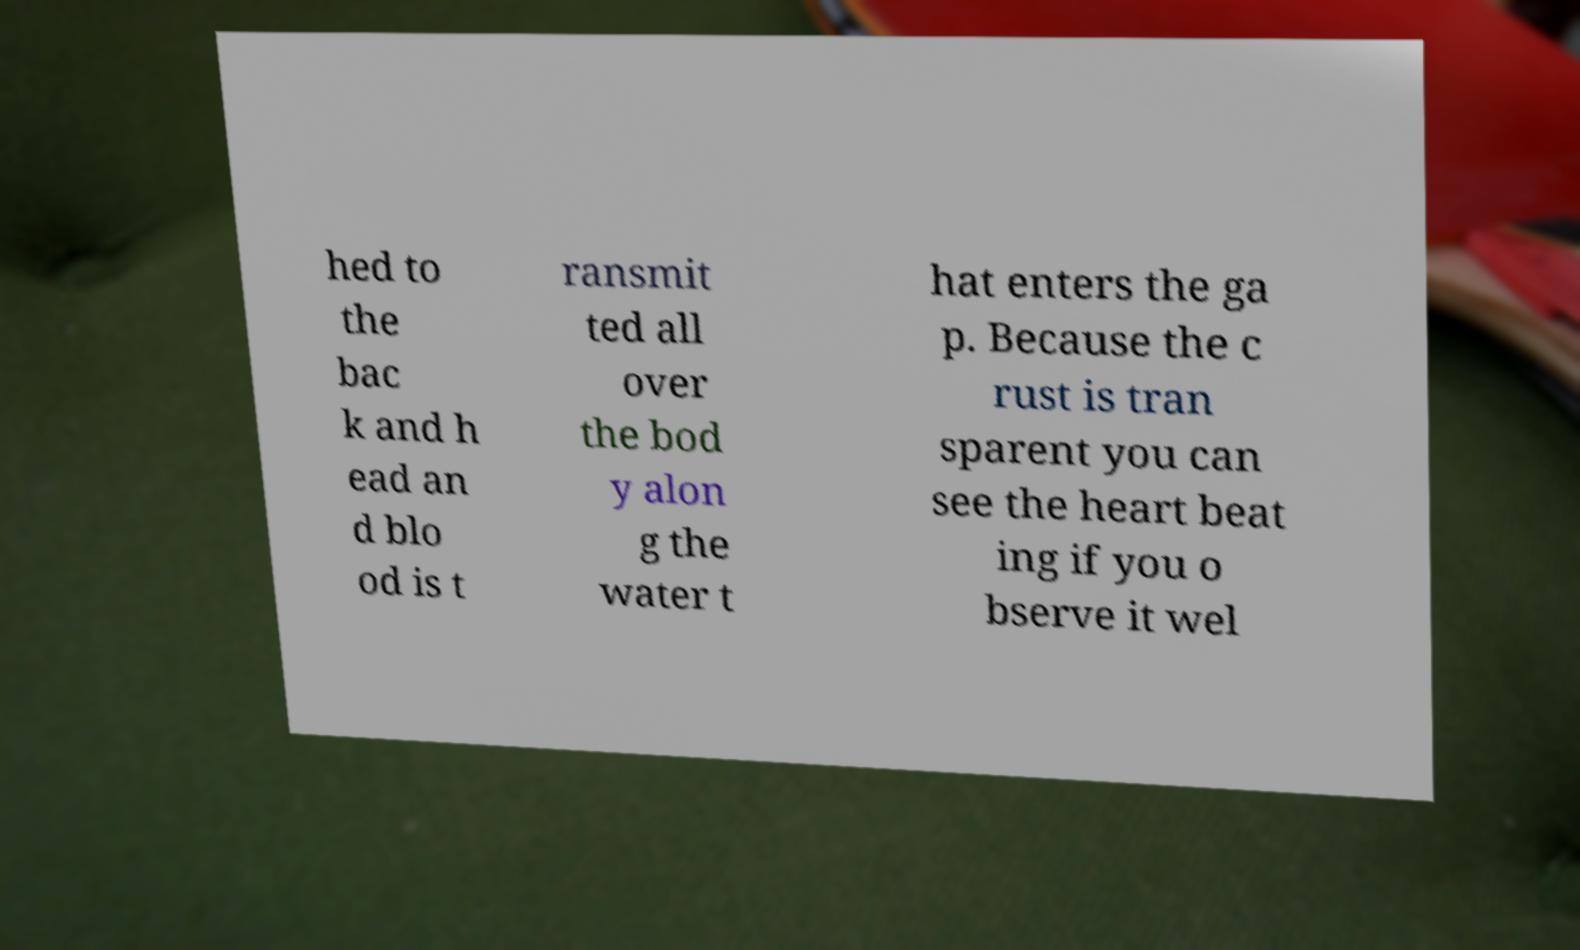Can you read and provide the text displayed in the image?This photo seems to have some interesting text. Can you extract and type it out for me? hed to the bac k and h ead an d blo od is t ransmit ted all over the bod y alon g the water t hat enters the ga p. Because the c rust is tran sparent you can see the heart beat ing if you o bserve it wel 